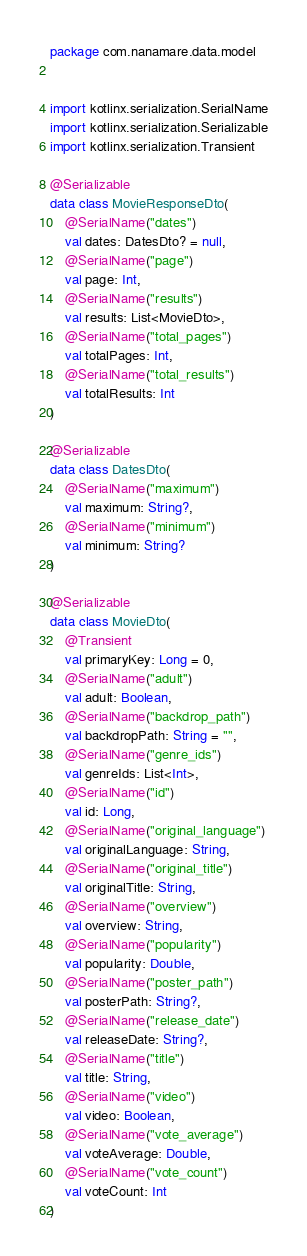Convert code to text. <code><loc_0><loc_0><loc_500><loc_500><_Kotlin_>package com.nanamare.data.model


import kotlinx.serialization.SerialName
import kotlinx.serialization.Serializable
import kotlinx.serialization.Transient

@Serializable
data class MovieResponseDto(
    @SerialName("dates")
    val dates: DatesDto? = null,
    @SerialName("page")
    val page: Int,
    @SerialName("results")
    val results: List<MovieDto>,
    @SerialName("total_pages")
    val totalPages: Int,
    @SerialName("total_results")
    val totalResults: Int
)

@Serializable
data class DatesDto(
    @SerialName("maximum")
    val maximum: String?,
    @SerialName("minimum")
    val minimum: String?
)

@Serializable
data class MovieDto(
    @Transient
    val primaryKey: Long = 0,
    @SerialName("adult")
    val adult: Boolean,
    @SerialName("backdrop_path")
    val backdropPath: String = "",
    @SerialName("genre_ids")
    val genreIds: List<Int>,
    @SerialName("id")
    val id: Long,
    @SerialName("original_language")
    val originalLanguage: String,
    @SerialName("original_title")
    val originalTitle: String,
    @SerialName("overview")
    val overview: String,
    @SerialName("popularity")
    val popularity: Double,
    @SerialName("poster_path")
    val posterPath: String?,
    @SerialName("release_date")
    val releaseDate: String?,
    @SerialName("title")
    val title: String,
    @SerialName("video")
    val video: Boolean,
    @SerialName("vote_average")
    val voteAverage: Double,
    @SerialName("vote_count")
    val voteCount: Int
)</code> 